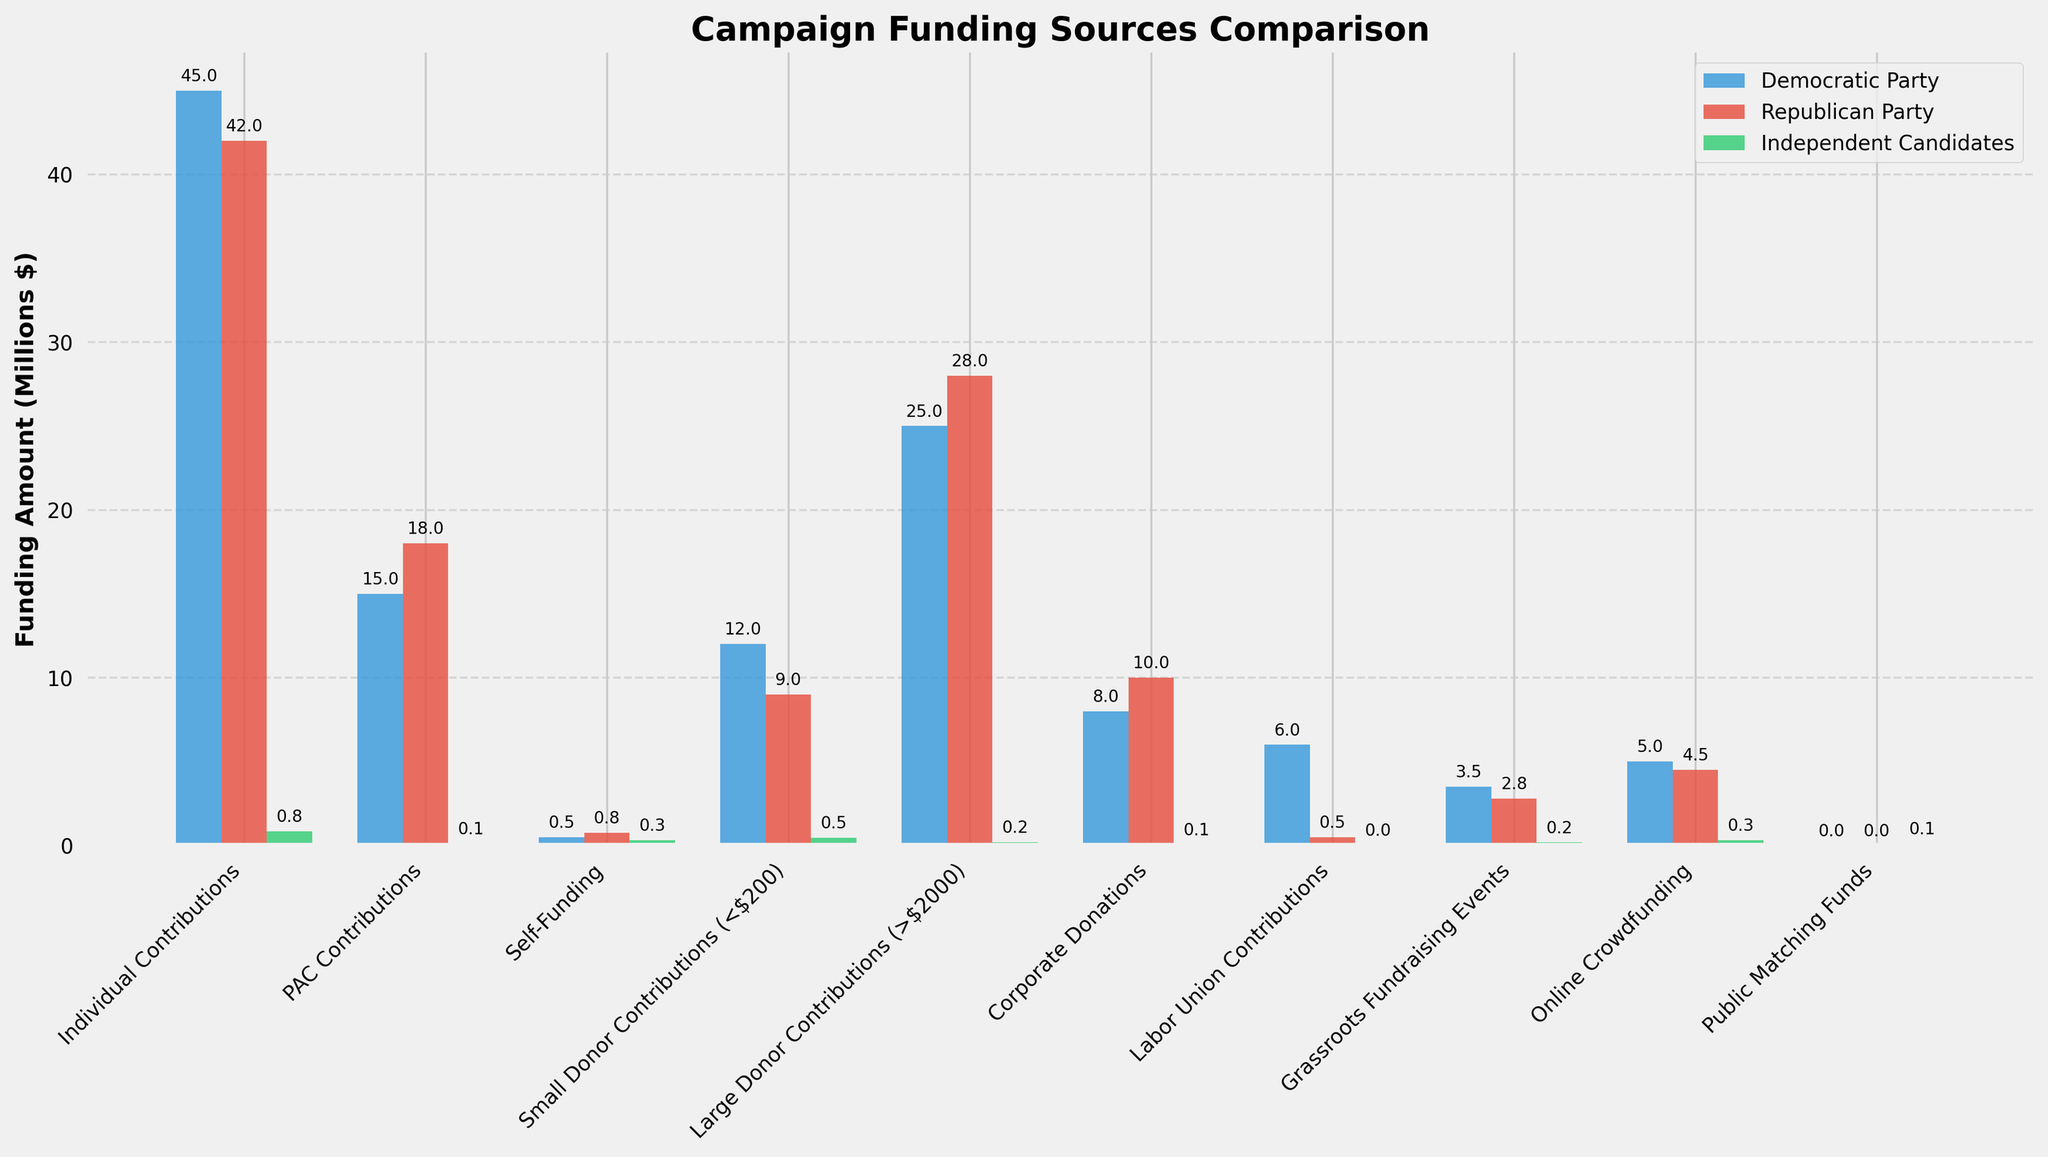What's the total campaign funding from Individual Contributions for all three groups? We need to add the contributions of the Democratic Party, Republican Party, and Independent Candidates for Individual Contributions. The values are $45,000,000, $42,000,000, and $850,000 respectively. Sum them up: $45,000,000 + $42,000,000 + $850,000 = $87,850,000.
Answer: $87,850,000 Which funding source category shows the least amount of funding for Independent Candidates? We examine each funding source category for the Independent Candidates and identify the one with the smallest value. The smallest value is $30,000 from Labor Union Contributions.
Answer: Labor Union Contributions How much more funding do Democratic Party candidates receive from PAC Contributions compared to Independent Candidates? To find the difference, subtract the PAC Contributions of Independent Candidates from the Democratic Party's PAC Contributions. The values are $15,000,000 for Democrats and $120,000 for Independents. The difference is $15,000,000 - $120,000 = $14,880,000.
Answer: $14,880,000 Which party receives the most funding from Large Donor Contributions? We compare the Large Donor Contributions for the Democratic Party, Republican Party, and Independent Candidates. The values are $25,000,000 (Democratic), $28,000,000 (Republican), and $200,000 (Independent). The highest value is $28,000,000 for the Republican Party.
Answer: Republican Party Between PAC Contributions and Self-Funding, which category provides more funding for Independent Candidates, and by how much? We calculate the difference between PAC Contributions and Self-Funding for Independent Candidates. The values are $120,000 (PAC) and $300,000 (Self-Funding). The difference is $300,000 - $120,000 = $180,000. Self-Funding is higher by $180,000.
Answer: Self-Funding by $180,000 What is the combined total of Corporate Donations and Online Crowdfunding for the Republican Party? We sum the Corporate Donations and Online Crowdfunding amounts for the Republican Party. The values are $10,000,000 (Corporate Donations) and $4,500,000 (Online Crowdfunding). The combined total is $10,000,000 + $4,500,000 = $14,500,000.
Answer: $14,500,000 Which funding source category has the smallest difference in funding between Democratic and Republican parties? We calculate the absolute difference between the Democratic Party and Republican Party for each funding source category and identify the smallest difference. The smallest difference is for Online Crowdfunding, calculated as $5,000,000 (Democratic) - $4,500,000 (Republican) = $500,000.
Answer: Online Crowdfunding How much funding do Independent Candidates receive from Grassroots Fundraising Events compared to Democratic and Republican parties combined? Add the amounts for the Democratic Party and Republican Party, and then compare to the amount for Independent Candidates. Democratic: $3,500,000, Republican: $2,800,000, Independent: $180,000. Combined amount for Democratic and Republican Parties: $3,500,000 + $2,800,000 = $6,300,000. Independent Candidates receive $180,000.
Answer: $180,000 compared to $6,300,000 Which group relies the most on Small Donor Contributions as a percentage of their total funding from individual, large donors, and small donors combined? First, calculate the total funding from individual, large, and small donors for each group. Democratic: $45,000,000 + $25,000,000 + $12,000,000 = $82,000,000. Republican: $42,000,000 + $28,000,000 + $9,000,000 = $79,000,000. Independent: $850,000 + $200,000 + $450,000 = $1,500,000. Then calculate the percentage of Small Donor Contributions. Democratic: $12,000,000/$82,000,000 * 100 ≈ 14.6%. Republican: $9,000,000/$79,000,000 * 100 ≈ 11.4%. Independent: $450,000/$1,500,000 * 100 ≈ 30%. Independents rely the most with ≈ 30%.
Answer: Independent Candidates with ≈ 30% 